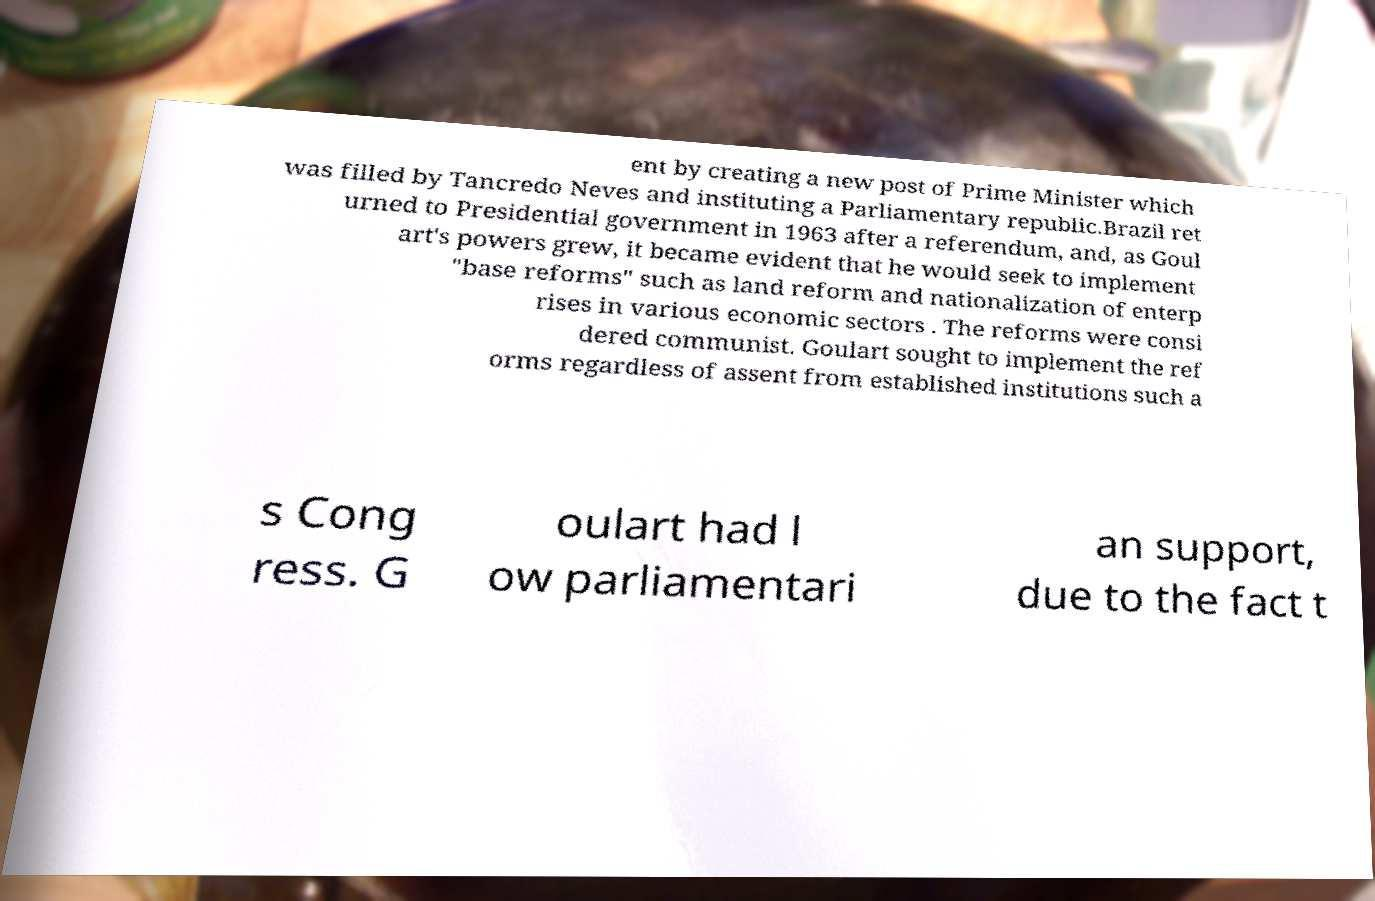For documentation purposes, I need the text within this image transcribed. Could you provide that? ent by creating a new post of Prime Minister which was filled by Tancredo Neves and instituting a Parliamentary republic.Brazil ret urned to Presidential government in 1963 after a referendum, and, as Goul art's powers grew, it became evident that he would seek to implement "base reforms" such as land reform and nationalization of enterp rises in various economic sectors . The reforms were consi dered communist. Goulart sought to implement the ref orms regardless of assent from established institutions such a s Cong ress. G oulart had l ow parliamentari an support, due to the fact t 